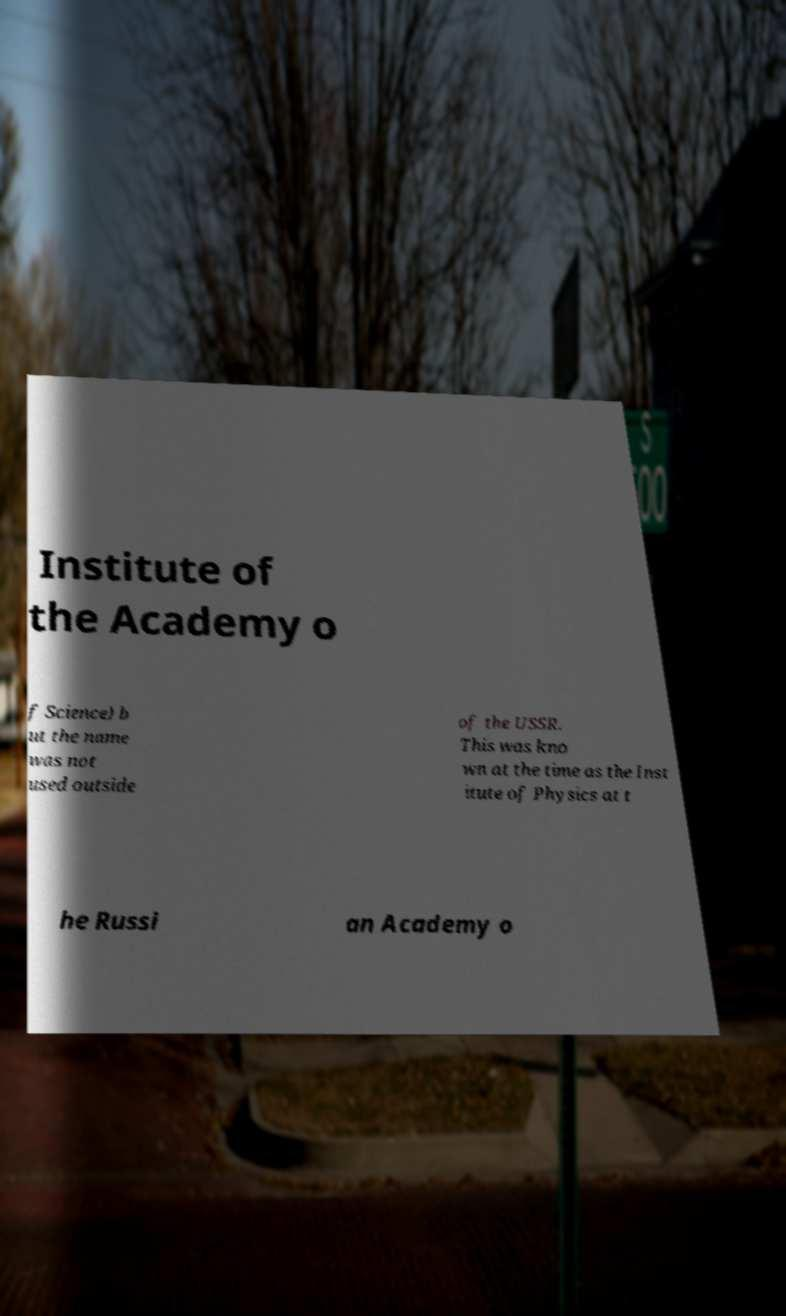I need the written content from this picture converted into text. Can you do that? Institute of the Academy o f Science) b ut the name was not used outside of the USSR. This was kno wn at the time as the Inst itute of Physics at t he Russi an Academy o 